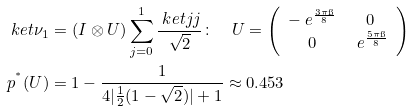<formula> <loc_0><loc_0><loc_500><loc_500>& \ k e t { \nu _ { 1 } } = ( I \otimes U ) \sum _ { j = 0 } ^ { 1 } \frac { \ k e t { j j } } { \sqrt { 2 } } \colon \quad U = \left ( \begin{array} { c c } - \ e ^ { \frac { 3 \pi \i } { 8 } } & 0 \\ 0 & \ e ^ { \frac { 5 \pi \i } { 8 } } \\ \end{array} \right ) \\ & p ^ { ^ { * } } ( U ) = 1 - \frac { 1 } { 4 | \frac { 1 } { 2 } ( 1 - \sqrt { 2 } ) | + 1 } \approx 0 . 4 5 3</formula> 